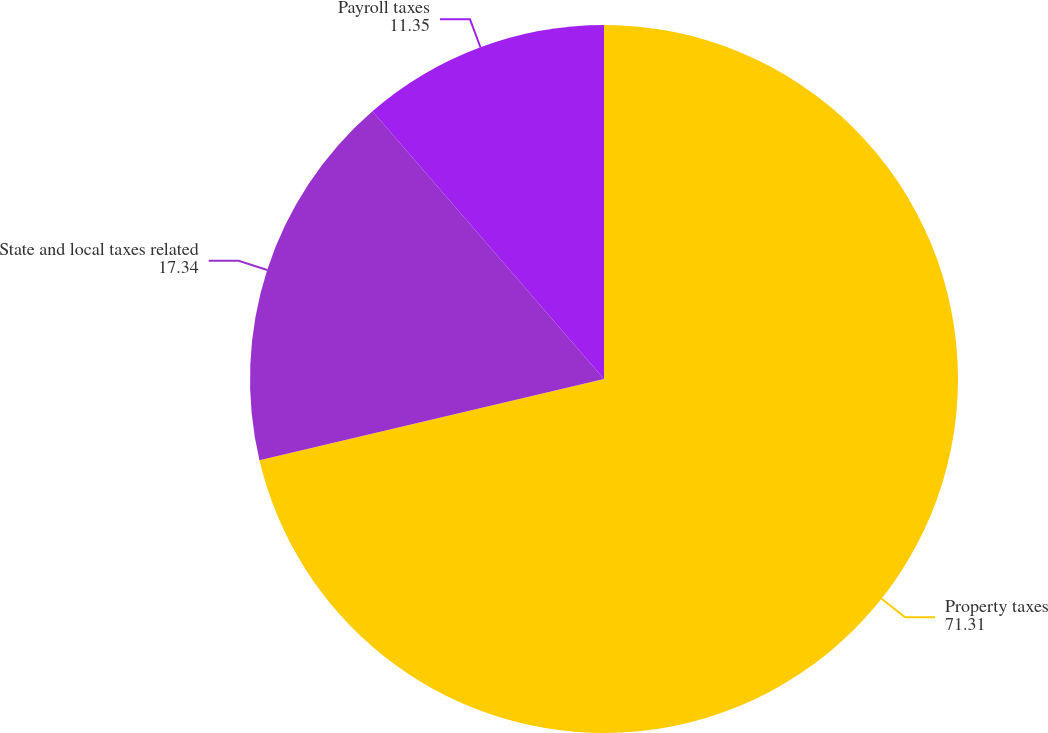Convert chart to OTSL. <chart><loc_0><loc_0><loc_500><loc_500><pie_chart><fcel>Property taxes<fcel>State and local taxes related<fcel>Payroll taxes<nl><fcel>71.31%<fcel>17.34%<fcel>11.35%<nl></chart> 